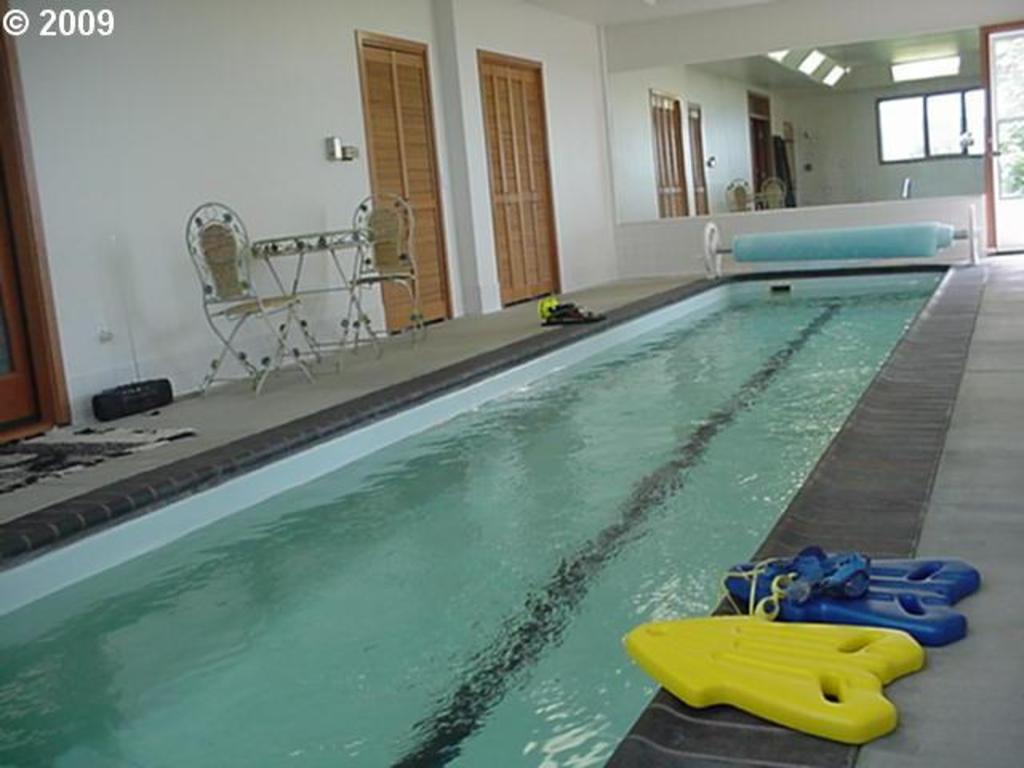In one or two sentences, can you explain what this image depicts? In this image we can see swimming pool, safety jackets, side tables, chairs, doormats, doors, windows and floor. 